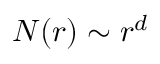Convert formula to latex. <formula><loc_0><loc_0><loc_500><loc_500>N ( r ) \sim r ^ { d }</formula> 